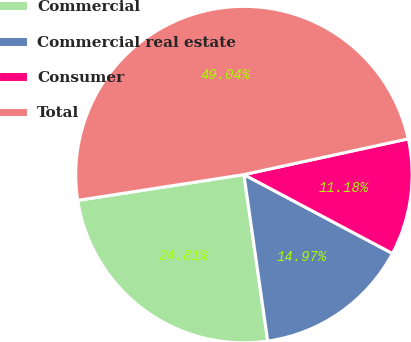Convert chart to OTSL. <chart><loc_0><loc_0><loc_500><loc_500><pie_chart><fcel>Commercial<fcel>Commercial real estate<fcel>Consumer<fcel>Total<nl><fcel>24.81%<fcel>14.97%<fcel>11.18%<fcel>49.04%<nl></chart> 